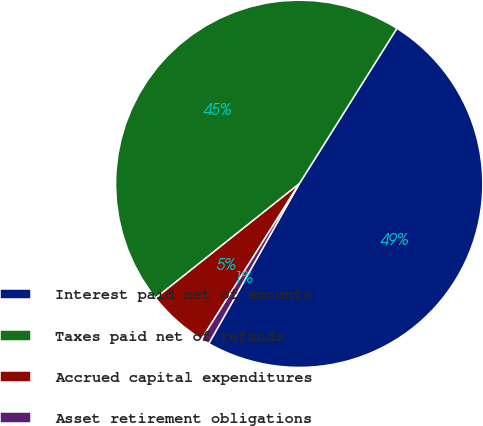Convert chart to OTSL. <chart><loc_0><loc_0><loc_500><loc_500><pie_chart><fcel>Interest paid net of amounts<fcel>Taxes paid net of refunds<fcel>Accrued capital expenditures<fcel>Asset retirement obligations<nl><fcel>49.27%<fcel>44.63%<fcel>5.37%<fcel>0.73%<nl></chart> 